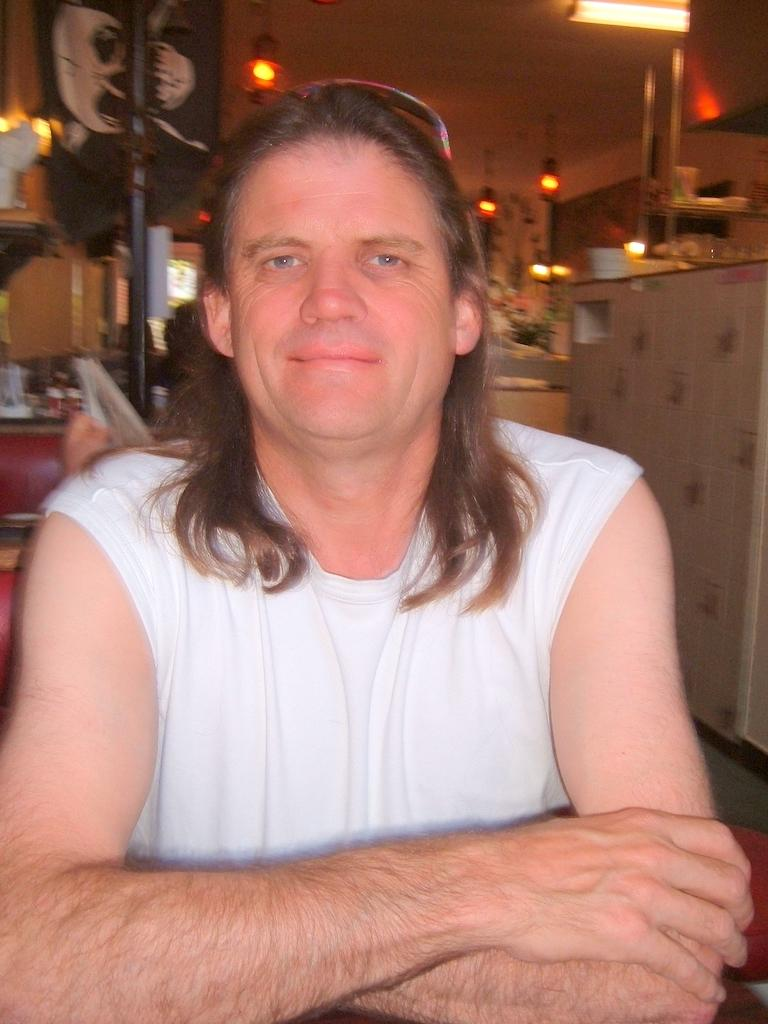What is the main subject of the image? There is a person in the image. What is the person wearing? The person is wearing a white dress. What can be seen in the background of the image? There is a black colored pole and the ceiling is visible in the background of the image. What is attached to the ceiling? There are lights attached to the ceiling. What other objects can be seen in the background of the image? There are other objects visible in the background of the image. What type of list is the person holding in the image? There is no list present in the image; the person is wearing a white dress and there are other objects visible in the background. What country is the person from in the image? The image does not provide any information about the person's nationality or country of origin. 